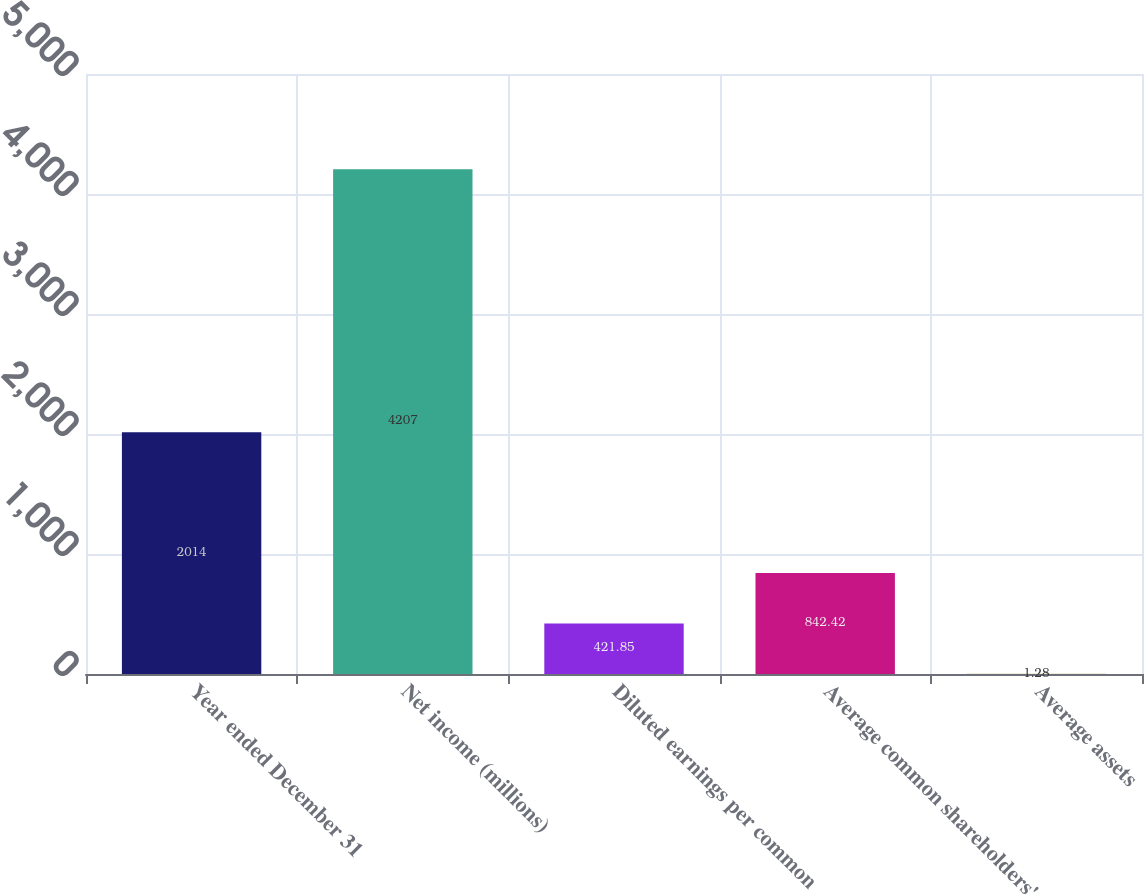Convert chart. <chart><loc_0><loc_0><loc_500><loc_500><bar_chart><fcel>Year ended December 31<fcel>Net income (millions)<fcel>Diluted earnings per common<fcel>Average common shareholders'<fcel>Average assets<nl><fcel>2014<fcel>4207<fcel>421.85<fcel>842.42<fcel>1.28<nl></chart> 